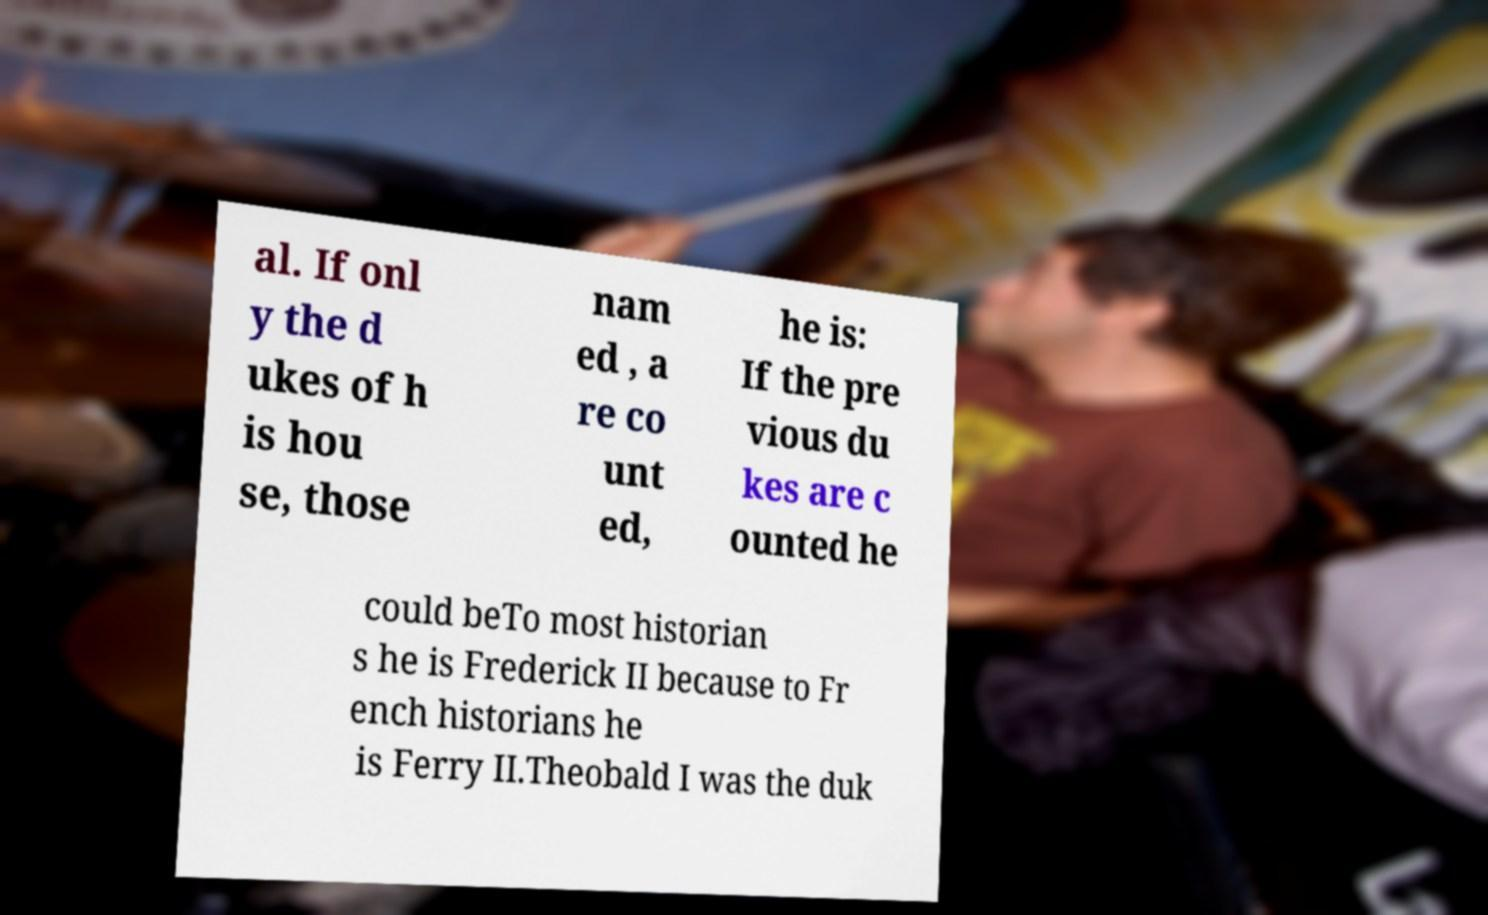Can you accurately transcribe the text from the provided image for me? al. If onl y the d ukes of h is hou se, those nam ed , a re co unt ed, he is: If the pre vious du kes are c ounted he could beTo most historian s he is Frederick II because to Fr ench historians he is Ferry II.Theobald I was the duk 